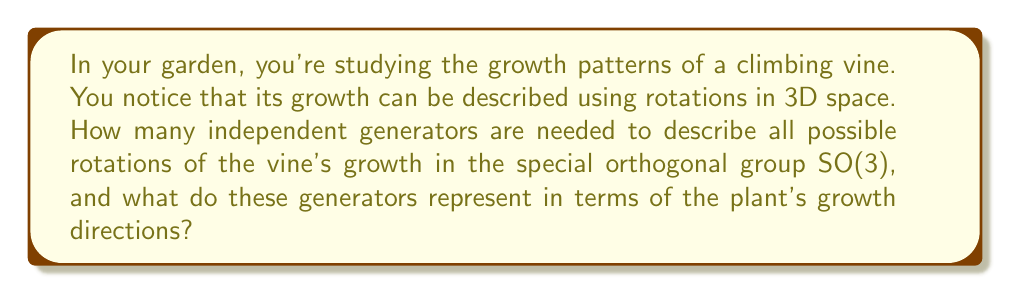Give your solution to this math problem. To answer this question, we need to analyze the Lie algebra of SO(3):

1. The special orthogonal group SO(3) represents all rotations in 3D space.

2. The Lie algebra so(3) of SO(3) consists of 3x3 skew-symmetric matrices:

   $$\begin{pmatrix}
   0 & -a & b \\
   a & 0 & -c \\
   -b & c & 0
   \end{pmatrix}$$

3. The dimension of so(3) is 3, which means there are 3 independent generators.

4. These generators can be represented as:

   $$J_1 = \begin{pmatrix}
   0 & 0 & 0 \\
   0 & 0 & -1 \\
   0 & 1 & 0
   \end{pmatrix},
   J_2 = \begin{pmatrix}
   0 & 0 & 1 \\
   0 & 0 & 0 \\
   -1 & 0 & 0
   \end{pmatrix},
   J_3 = \begin{pmatrix}
   0 & -1 & 0 \\
   1 & 0 & 0 \\
   0 & 0 & 0
   \end{pmatrix}$$

5. In terms of plant growth:
   - $J_1$ represents rotation around the x-axis (e.g., east-west direction)
   - $J_2$ represents rotation around the y-axis (e.g., north-south direction)
   - $J_3$ represents rotation around the z-axis (e.g., vertical direction)

6. Any rotation of the vine's growth can be described as a combination of these three basic rotations.
Answer: 3 generators, representing rotations around east-west, north-south, and vertical axes. 